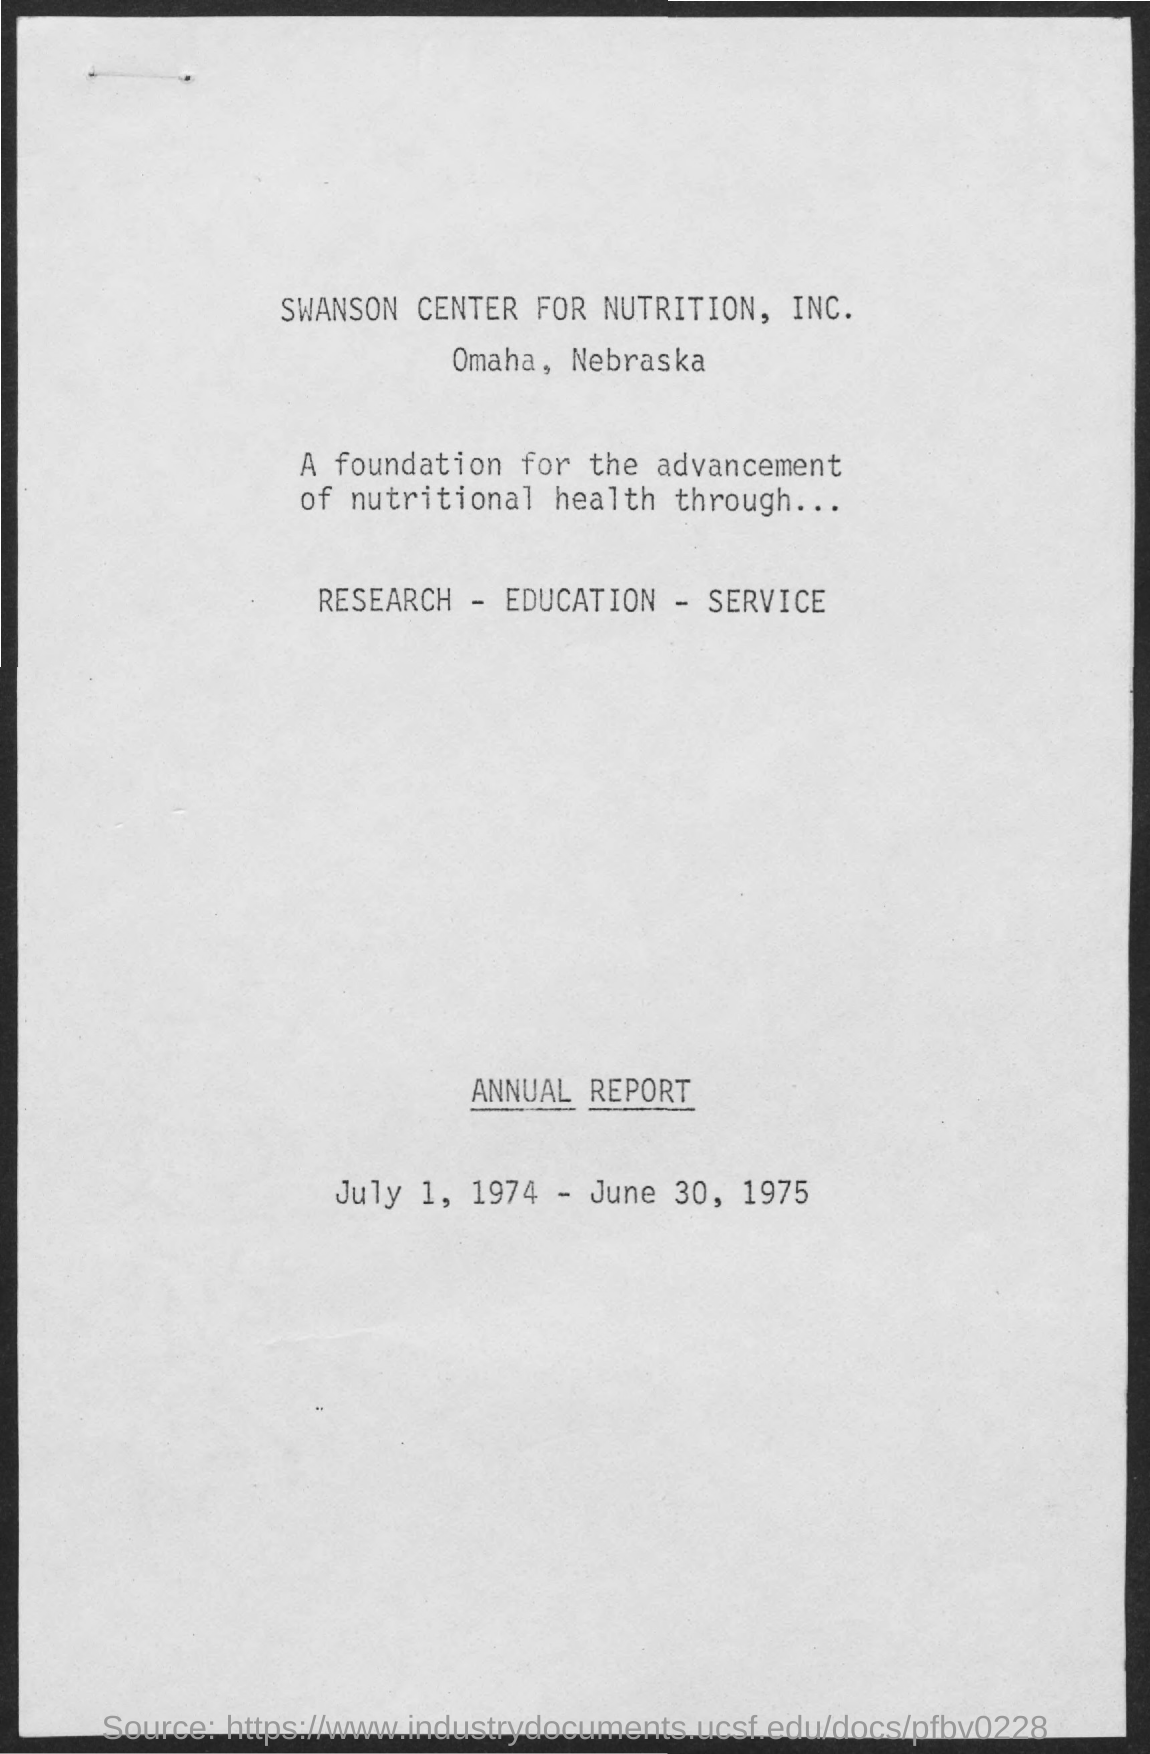Point out several critical features in this image. The duration of the annual report is from July 1, 1974 to June 30, 1975. The location of Swanson Center for Nutrition, Inc. is Omaha, Nebraska. 